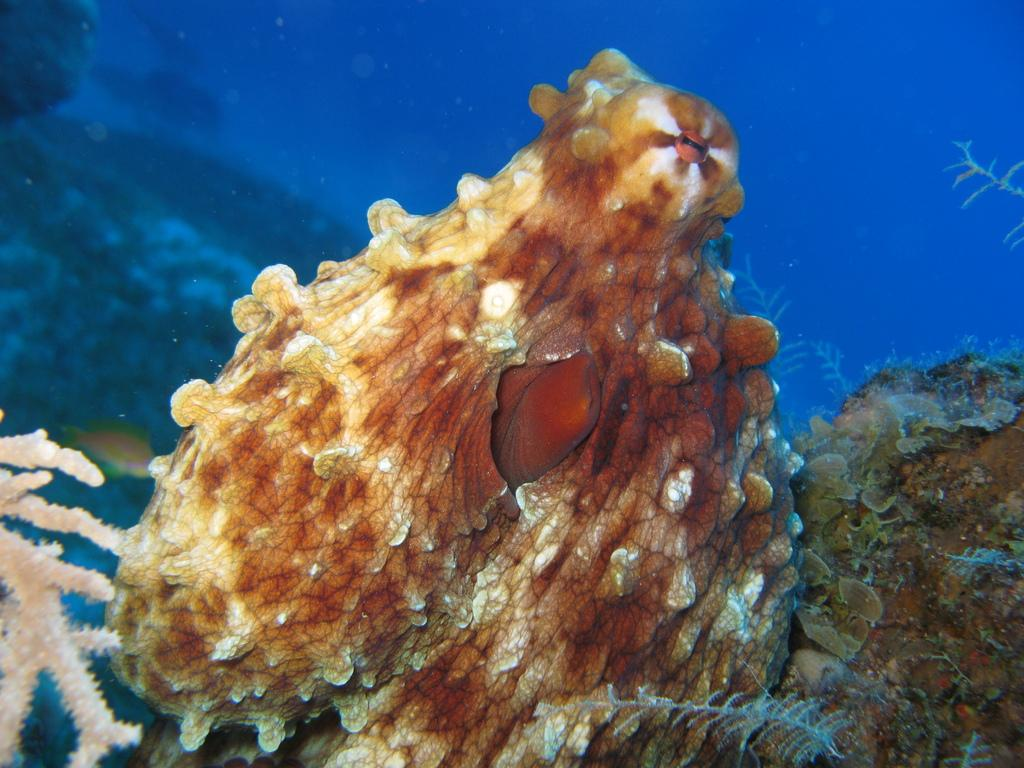What type of view is depicted in the image? The image is a zoomed-in view. What can be seen in the foreground of the image? There are marine objects in the foreground. What is located on the left side of the image? There is a marine plant on the left side of the image. What is visible in the background of the image? There is water visible in the background of the image. What type of destruction can be seen in the image? There is no destruction present in the image; it features marine objects and a marine plant in water. How many drops of water are visible in the image? It is not possible to count individual drops of water in the image, as it shows a general view of water in the background. 